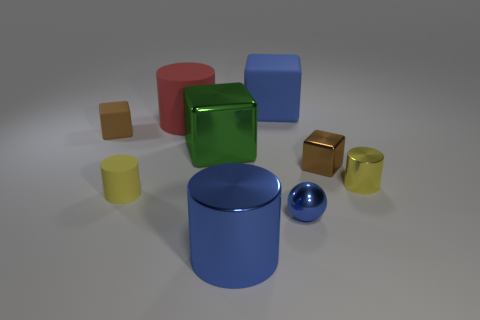Subtract all tiny yellow metal cylinders. How many cylinders are left? 3 Subtract 2 cubes. How many cubes are left? 2 Subtract all red cubes. How many yellow cylinders are left? 2 Subtract all green blocks. How many blocks are left? 3 Add 1 large gray objects. How many large gray objects exist? 1 Subtract 0 purple cubes. How many objects are left? 9 Subtract all cubes. How many objects are left? 5 Subtract all blue cubes. Subtract all blue cylinders. How many cubes are left? 3 Subtract all tiny green matte spheres. Subtract all large metallic cylinders. How many objects are left? 8 Add 6 tiny metal balls. How many tiny metal balls are left? 7 